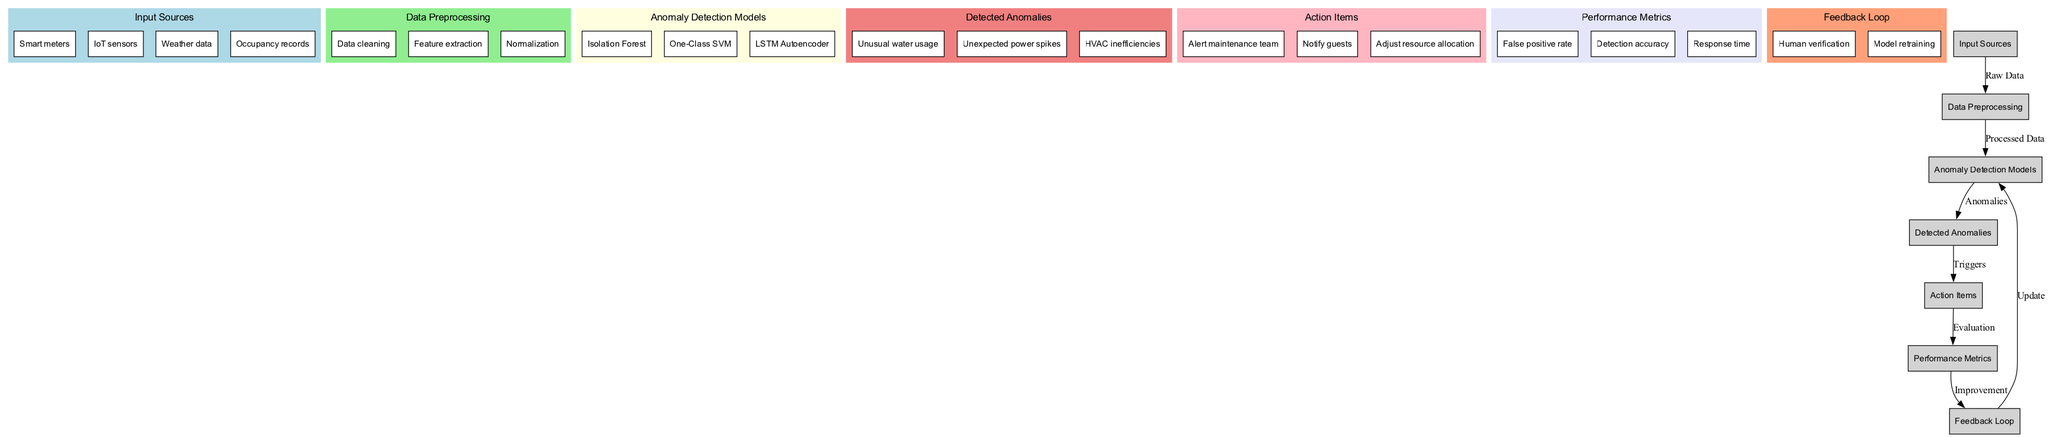What are the input sources for the anomaly detection system? The diagram lists "Smart meters," "IoT sensors," "Weather data," and "Occupancy records" as input sources.
Answer: Smart meters, IoT sensors, Weather data, Occupancy records How many anomaly detection models are represented in the diagram? The diagram shows three models: "Isolation Forest," "One-Class SVM," and "LSTM Autoencoder," indicating that there are three models total.
Answer: 3 What is the relationship between detected anomalies and action items? The diagram indicates that the detected anomalies lead to action items through the trigger label, demonstrating a direct flow from "Detected Anomalies" to "Action Items."
Answer: Triggers Which data preprocessing step appears first in the diagram? The data preprocessing steps include "Data cleaning," "Feature extraction," and "Normalization," arranged in order, making "Data cleaning" the first step.
Answer: Data cleaning What performance metric relates to the speed of response to detected anomalies? The performance metrics include "False positive rate," "Detection accuracy," and "Response time," with "Response time" specifically indicating the speed of response.
Answer: Response time What action is triggered by unusual water usage? The diagram leads from "Detected Anomalies" to "Action Items", indicating that the action triggered is, for example, "Alert maintenance team."
Answer: Alert maintenance team How does the feedback loop affect the anomaly detection models? The feedback loop, labeled "update," shows that feedback from performance metrics influences and directly updates the anomaly detection models, ensuring they improve over time.
Answer: Update What anomaly was detected related to HVAC systems? Among the detected anomalies, "HVAC inefficiencies" specifically relates to problems detected within HVAC systems, as outlined in the diagram.
Answer: HVAC inefficiencies 